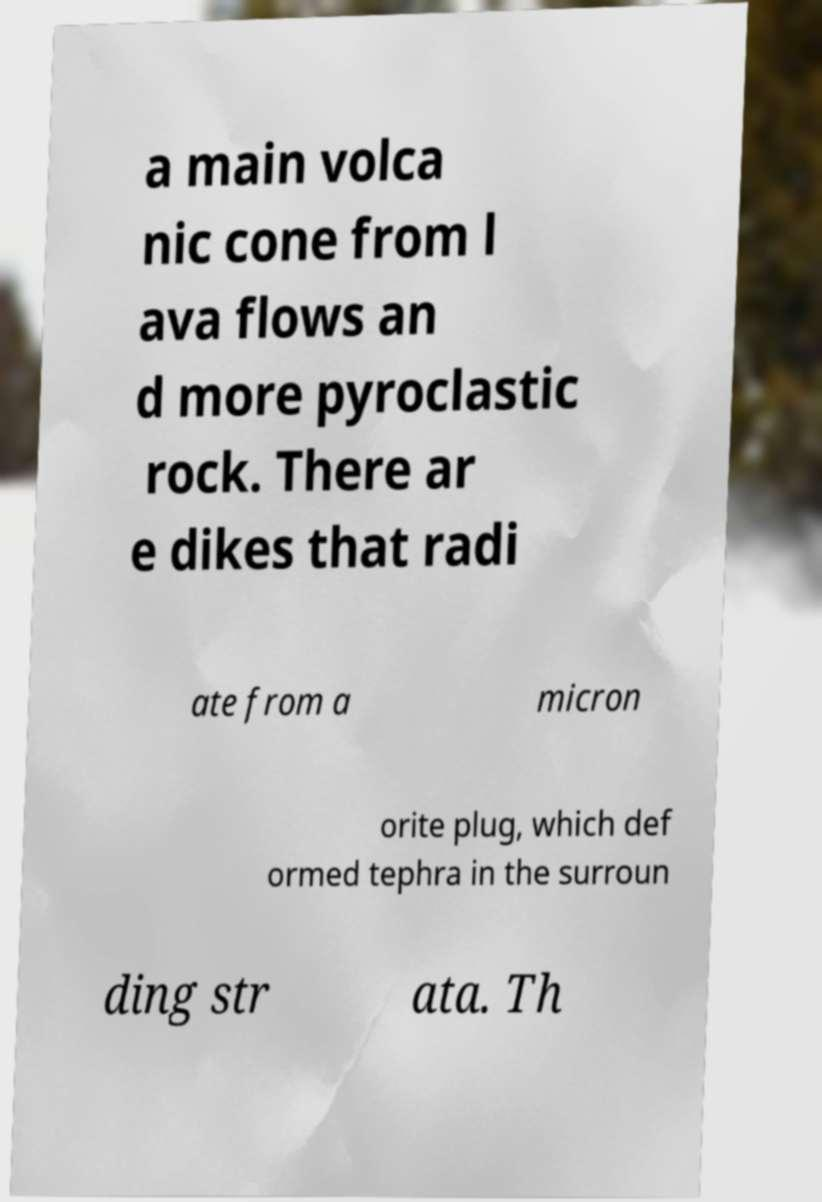Can you accurately transcribe the text from the provided image for me? a main volca nic cone from l ava flows an d more pyroclastic rock. There ar e dikes that radi ate from a micron orite plug, which def ormed tephra in the surroun ding str ata. Th 